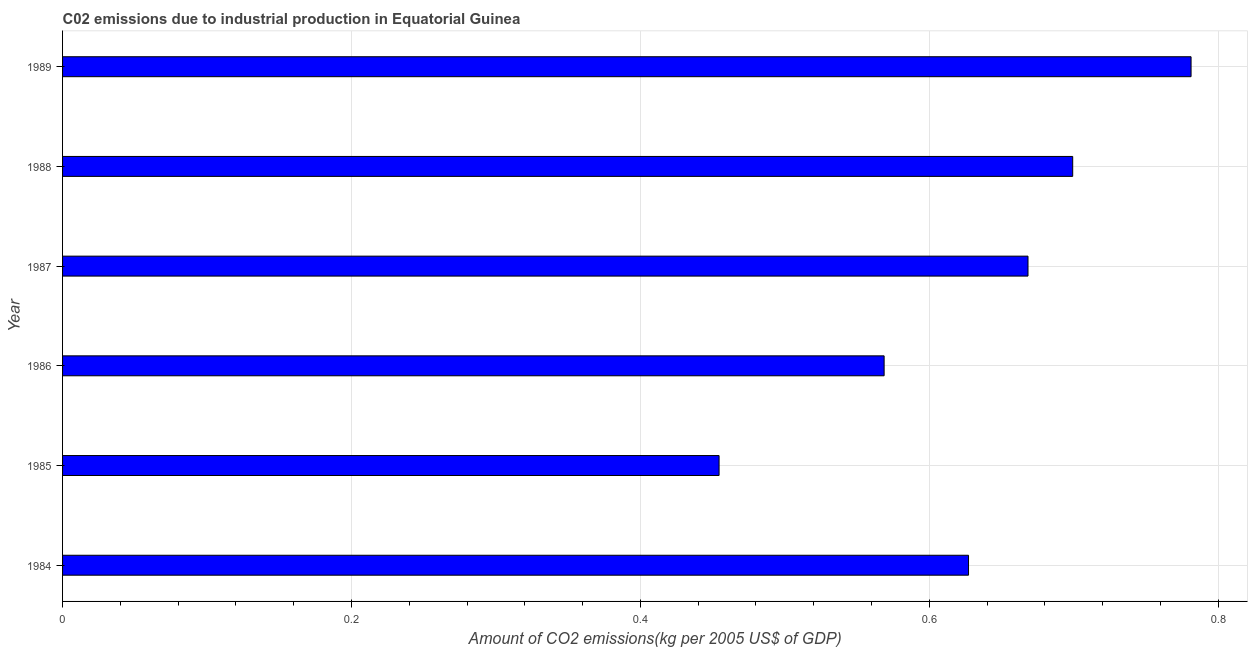Does the graph contain any zero values?
Your response must be concise. No. Does the graph contain grids?
Ensure brevity in your answer.  Yes. What is the title of the graph?
Make the answer very short. C02 emissions due to industrial production in Equatorial Guinea. What is the label or title of the X-axis?
Give a very brief answer. Amount of CO2 emissions(kg per 2005 US$ of GDP). What is the amount of co2 emissions in 1985?
Offer a terse response. 0.45. Across all years, what is the maximum amount of co2 emissions?
Make the answer very short. 0.78. Across all years, what is the minimum amount of co2 emissions?
Keep it short and to the point. 0.45. In which year was the amount of co2 emissions maximum?
Give a very brief answer. 1989. What is the sum of the amount of co2 emissions?
Provide a short and direct response. 3.8. What is the difference between the amount of co2 emissions in 1984 and 1986?
Offer a very short reply. 0.06. What is the average amount of co2 emissions per year?
Your response must be concise. 0.63. What is the median amount of co2 emissions?
Keep it short and to the point. 0.65. In how many years, is the amount of co2 emissions greater than 0.2 kg per 2005 US$ of GDP?
Give a very brief answer. 6. What is the ratio of the amount of co2 emissions in 1985 to that in 1989?
Make the answer very short. 0.58. Is the amount of co2 emissions in 1984 less than that in 1989?
Make the answer very short. Yes. What is the difference between the highest and the second highest amount of co2 emissions?
Your response must be concise. 0.08. Is the sum of the amount of co2 emissions in 1987 and 1989 greater than the maximum amount of co2 emissions across all years?
Offer a very short reply. Yes. What is the difference between the highest and the lowest amount of co2 emissions?
Offer a terse response. 0.33. How many bars are there?
Your answer should be very brief. 6. How many years are there in the graph?
Your answer should be very brief. 6. What is the difference between two consecutive major ticks on the X-axis?
Your answer should be compact. 0.2. What is the Amount of CO2 emissions(kg per 2005 US$ of GDP) of 1984?
Your response must be concise. 0.63. What is the Amount of CO2 emissions(kg per 2005 US$ of GDP) in 1985?
Provide a succinct answer. 0.45. What is the Amount of CO2 emissions(kg per 2005 US$ of GDP) of 1986?
Ensure brevity in your answer.  0.57. What is the Amount of CO2 emissions(kg per 2005 US$ of GDP) of 1987?
Provide a short and direct response. 0.67. What is the Amount of CO2 emissions(kg per 2005 US$ of GDP) in 1988?
Give a very brief answer. 0.7. What is the Amount of CO2 emissions(kg per 2005 US$ of GDP) in 1989?
Offer a very short reply. 0.78. What is the difference between the Amount of CO2 emissions(kg per 2005 US$ of GDP) in 1984 and 1985?
Your answer should be compact. 0.17. What is the difference between the Amount of CO2 emissions(kg per 2005 US$ of GDP) in 1984 and 1986?
Make the answer very short. 0.06. What is the difference between the Amount of CO2 emissions(kg per 2005 US$ of GDP) in 1984 and 1987?
Make the answer very short. -0.04. What is the difference between the Amount of CO2 emissions(kg per 2005 US$ of GDP) in 1984 and 1988?
Offer a terse response. -0.07. What is the difference between the Amount of CO2 emissions(kg per 2005 US$ of GDP) in 1984 and 1989?
Make the answer very short. -0.15. What is the difference between the Amount of CO2 emissions(kg per 2005 US$ of GDP) in 1985 and 1986?
Provide a short and direct response. -0.11. What is the difference between the Amount of CO2 emissions(kg per 2005 US$ of GDP) in 1985 and 1987?
Keep it short and to the point. -0.21. What is the difference between the Amount of CO2 emissions(kg per 2005 US$ of GDP) in 1985 and 1988?
Offer a very short reply. -0.24. What is the difference between the Amount of CO2 emissions(kg per 2005 US$ of GDP) in 1985 and 1989?
Give a very brief answer. -0.33. What is the difference between the Amount of CO2 emissions(kg per 2005 US$ of GDP) in 1986 and 1987?
Your answer should be very brief. -0.1. What is the difference between the Amount of CO2 emissions(kg per 2005 US$ of GDP) in 1986 and 1988?
Your answer should be compact. -0.13. What is the difference between the Amount of CO2 emissions(kg per 2005 US$ of GDP) in 1986 and 1989?
Your answer should be very brief. -0.21. What is the difference between the Amount of CO2 emissions(kg per 2005 US$ of GDP) in 1987 and 1988?
Provide a short and direct response. -0.03. What is the difference between the Amount of CO2 emissions(kg per 2005 US$ of GDP) in 1987 and 1989?
Provide a short and direct response. -0.11. What is the difference between the Amount of CO2 emissions(kg per 2005 US$ of GDP) in 1988 and 1989?
Offer a very short reply. -0.08. What is the ratio of the Amount of CO2 emissions(kg per 2005 US$ of GDP) in 1984 to that in 1985?
Provide a succinct answer. 1.38. What is the ratio of the Amount of CO2 emissions(kg per 2005 US$ of GDP) in 1984 to that in 1986?
Your answer should be compact. 1.1. What is the ratio of the Amount of CO2 emissions(kg per 2005 US$ of GDP) in 1984 to that in 1987?
Your answer should be very brief. 0.94. What is the ratio of the Amount of CO2 emissions(kg per 2005 US$ of GDP) in 1984 to that in 1988?
Your response must be concise. 0.9. What is the ratio of the Amount of CO2 emissions(kg per 2005 US$ of GDP) in 1984 to that in 1989?
Provide a succinct answer. 0.8. What is the ratio of the Amount of CO2 emissions(kg per 2005 US$ of GDP) in 1985 to that in 1986?
Your answer should be very brief. 0.8. What is the ratio of the Amount of CO2 emissions(kg per 2005 US$ of GDP) in 1985 to that in 1987?
Your answer should be very brief. 0.68. What is the ratio of the Amount of CO2 emissions(kg per 2005 US$ of GDP) in 1985 to that in 1988?
Your response must be concise. 0.65. What is the ratio of the Amount of CO2 emissions(kg per 2005 US$ of GDP) in 1985 to that in 1989?
Provide a short and direct response. 0.58. What is the ratio of the Amount of CO2 emissions(kg per 2005 US$ of GDP) in 1986 to that in 1987?
Keep it short and to the point. 0.85. What is the ratio of the Amount of CO2 emissions(kg per 2005 US$ of GDP) in 1986 to that in 1988?
Your answer should be very brief. 0.81. What is the ratio of the Amount of CO2 emissions(kg per 2005 US$ of GDP) in 1986 to that in 1989?
Make the answer very short. 0.73. What is the ratio of the Amount of CO2 emissions(kg per 2005 US$ of GDP) in 1987 to that in 1988?
Keep it short and to the point. 0.96. What is the ratio of the Amount of CO2 emissions(kg per 2005 US$ of GDP) in 1987 to that in 1989?
Give a very brief answer. 0.86. What is the ratio of the Amount of CO2 emissions(kg per 2005 US$ of GDP) in 1988 to that in 1989?
Provide a succinct answer. 0.9. 